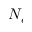<formula> <loc_0><loc_0><loc_500><loc_500>N _ { e }</formula> 